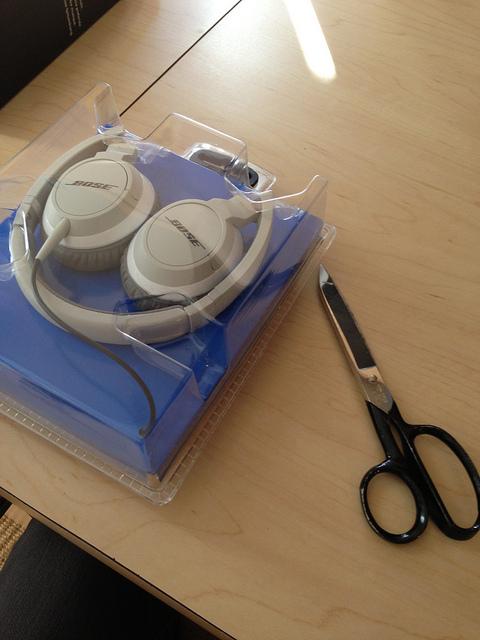What color are the headphones on the left?
Answer briefly. White. What is the item in the package?
Give a very brief answer. Headphones. What color are the handle on the scissors?
Short answer required. Black. What is the name of the sharp object?
Give a very brief answer. Scissors. 